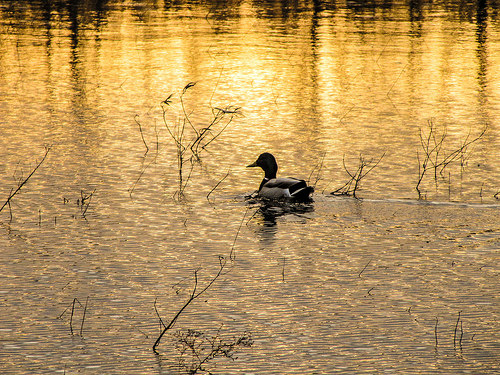<image>
Can you confirm if the water is under the duck? Yes. The water is positioned underneath the duck, with the duck above it in the vertical space. 